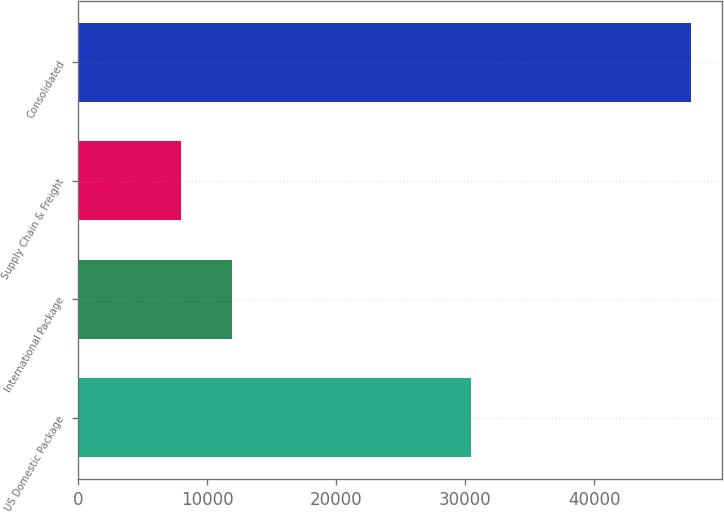Convert chart to OTSL. <chart><loc_0><loc_0><loc_500><loc_500><bar_chart><fcel>US Domestic Package<fcel>International Package<fcel>Supply Chain & Freight<fcel>Consolidated<nl><fcel>30456<fcel>11956.5<fcel>8002<fcel>47547<nl></chart> 